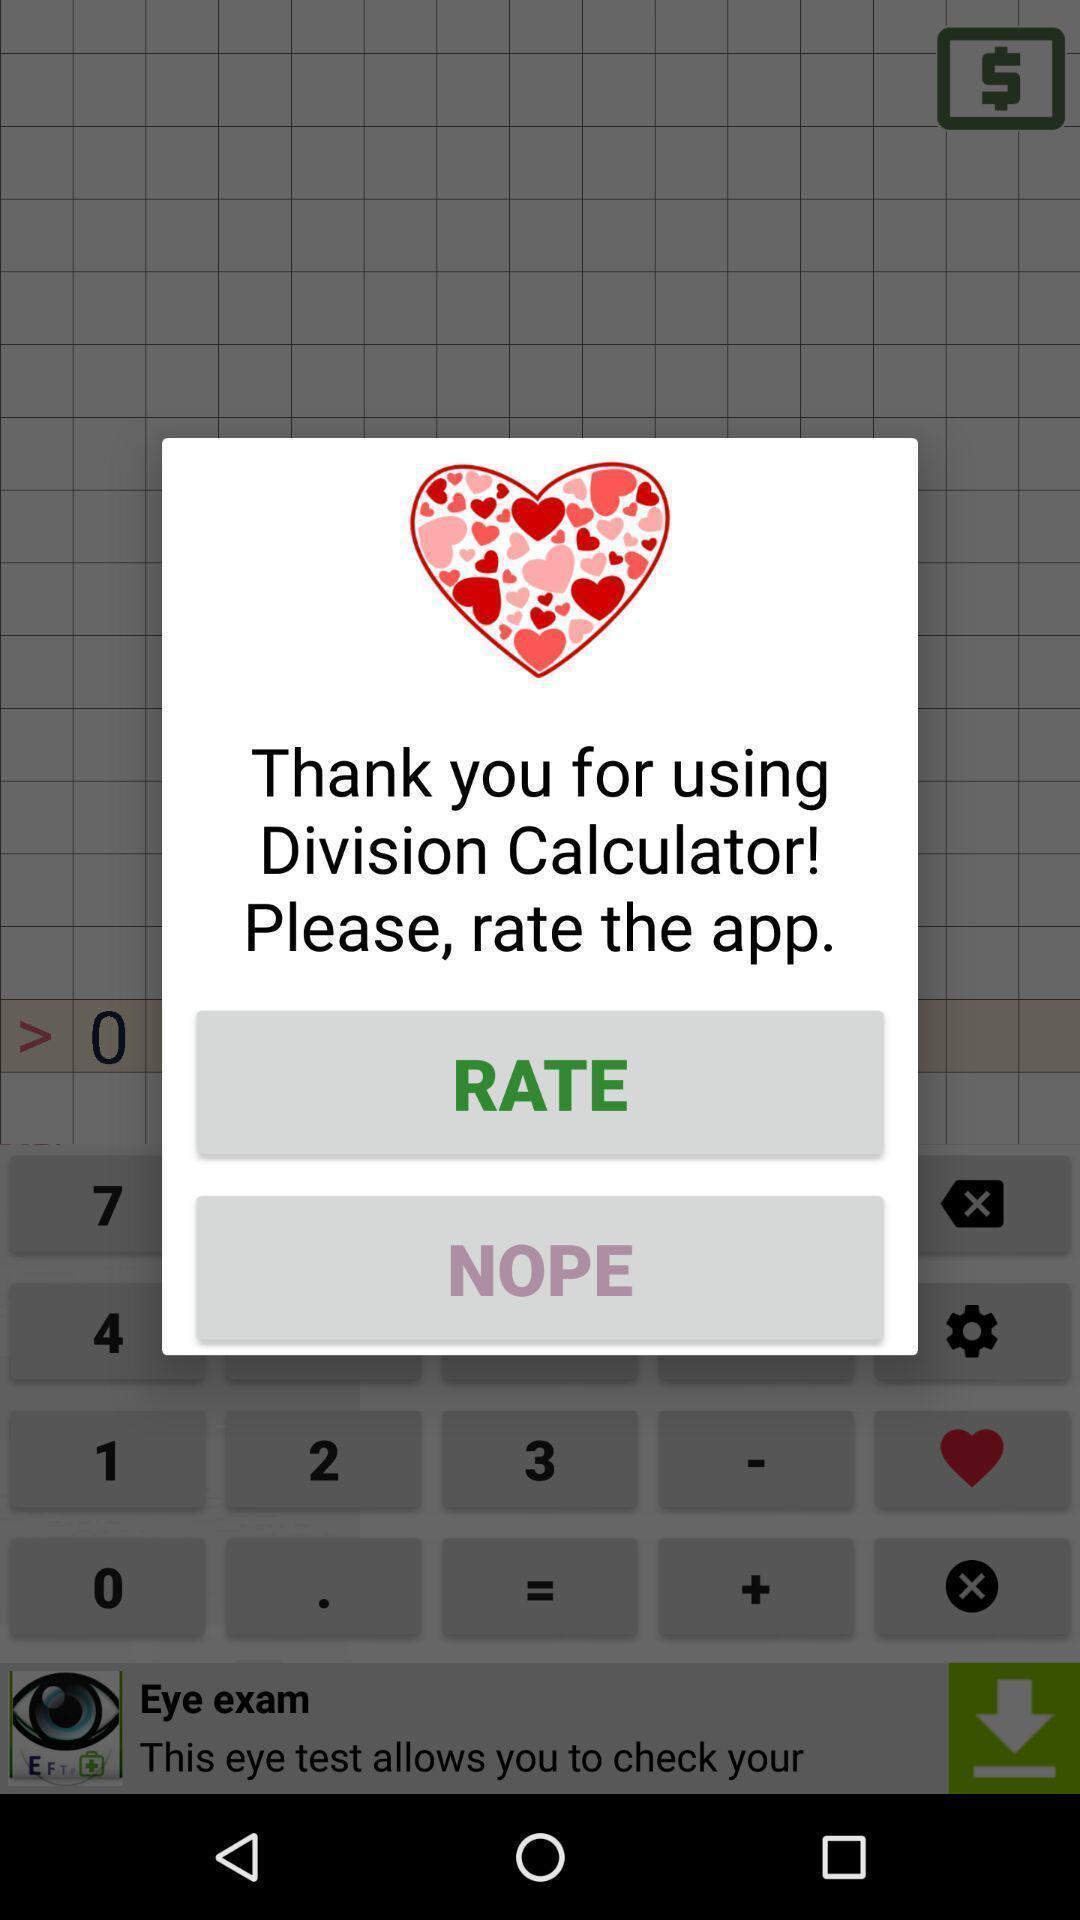What is the overall content of this screenshot? Pop-up screen for rating the application. 